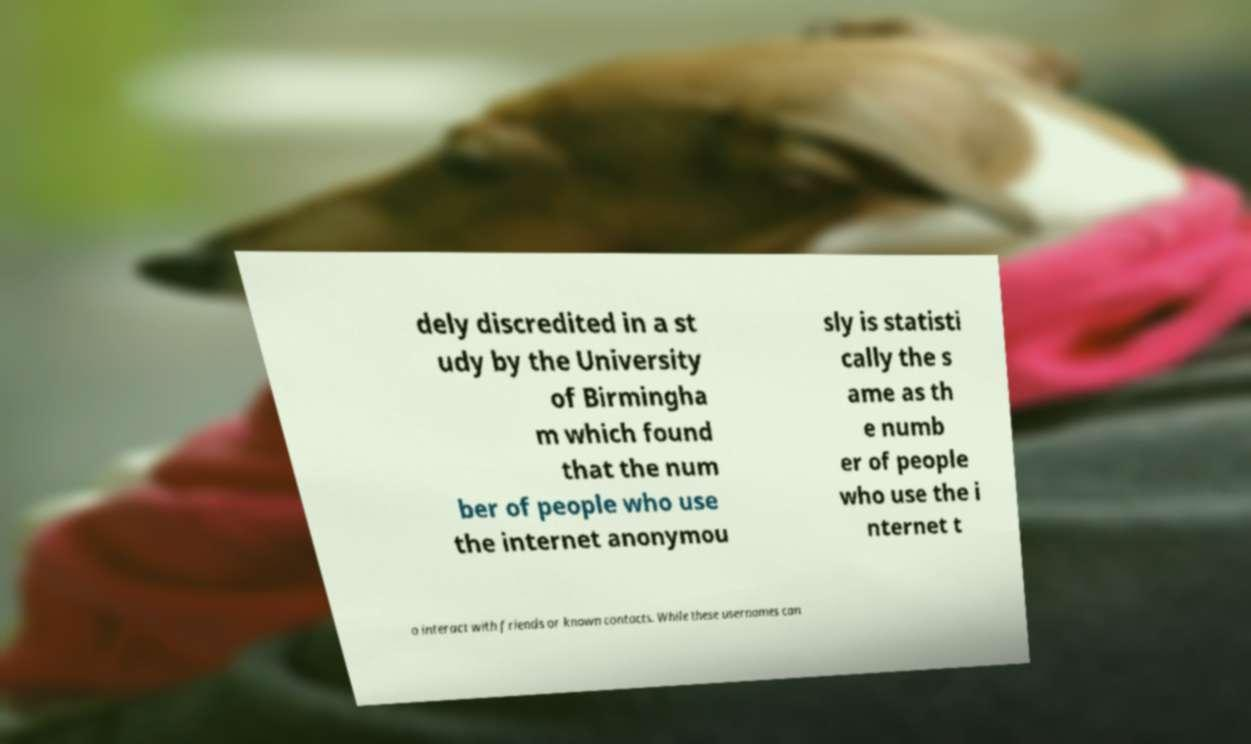For documentation purposes, I need the text within this image transcribed. Could you provide that? dely discredited in a st udy by the University of Birmingha m which found that the num ber of people who use the internet anonymou sly is statisti cally the s ame as th e numb er of people who use the i nternet t o interact with friends or known contacts. While these usernames can 